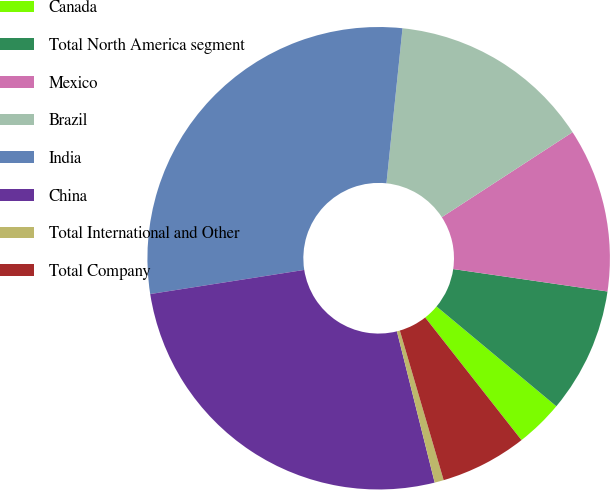Convert chart to OTSL. <chart><loc_0><loc_0><loc_500><loc_500><pie_chart><fcel>Canada<fcel>Total North America segment<fcel>Mexico<fcel>Brazil<fcel>India<fcel>China<fcel>Total International and Other<fcel>Total Company<nl><fcel>3.35%<fcel>8.76%<fcel>11.47%<fcel>14.18%<fcel>29.12%<fcel>26.42%<fcel>0.64%<fcel>6.06%<nl></chart> 